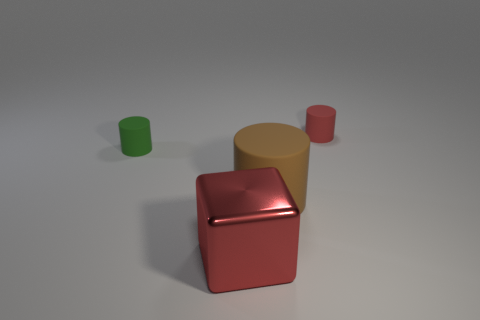Subtract all large rubber cylinders. How many cylinders are left? 2 Add 1 blocks. How many objects exist? 5 Subtract 2 cylinders. How many cylinders are left? 1 Subtract all blocks. How many objects are left? 3 Subtract all brown cylinders. How many cylinders are left? 2 Subtract all red cylinders. Subtract all gray balls. How many cylinders are left? 2 Subtract all big matte cylinders. Subtract all tiny red metal spheres. How many objects are left? 3 Add 4 large metal things. How many large metal things are left? 5 Add 3 cylinders. How many cylinders exist? 6 Subtract 0 purple cubes. How many objects are left? 4 